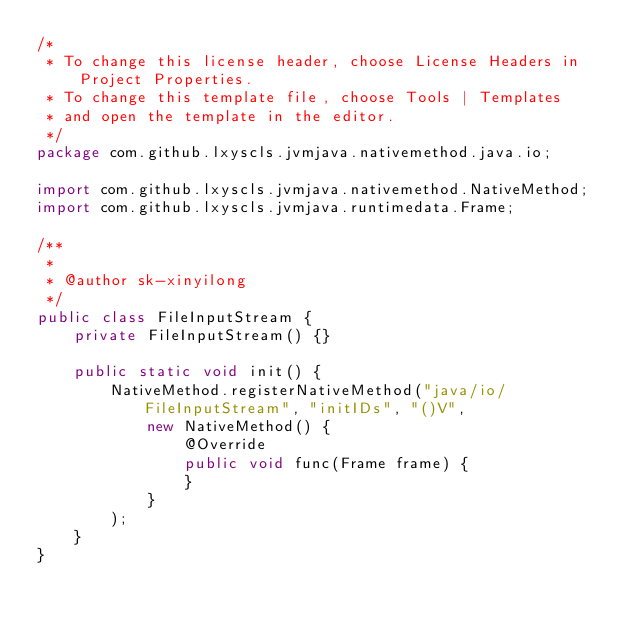<code> <loc_0><loc_0><loc_500><loc_500><_Java_>/*
 * To change this license header, choose License Headers in Project Properties.
 * To change this template file, choose Tools | Templates
 * and open the template in the editor.
 */
package com.github.lxyscls.jvmjava.nativemethod.java.io;

import com.github.lxyscls.jvmjava.nativemethod.NativeMethod;
import com.github.lxyscls.jvmjava.runtimedata.Frame;

/**
 *
 * @author sk-xinyilong
 */
public class FileInputStream {
    private FileInputStream() {}
    
    public static void init() {
        NativeMethod.registerNativeMethod("java/io/FileInputStream", "initIDs", "()V",
            new NativeMethod() {
                @Override
                public void func(Frame frame) {
                }
            }
        );      
    }       
}
</code> 